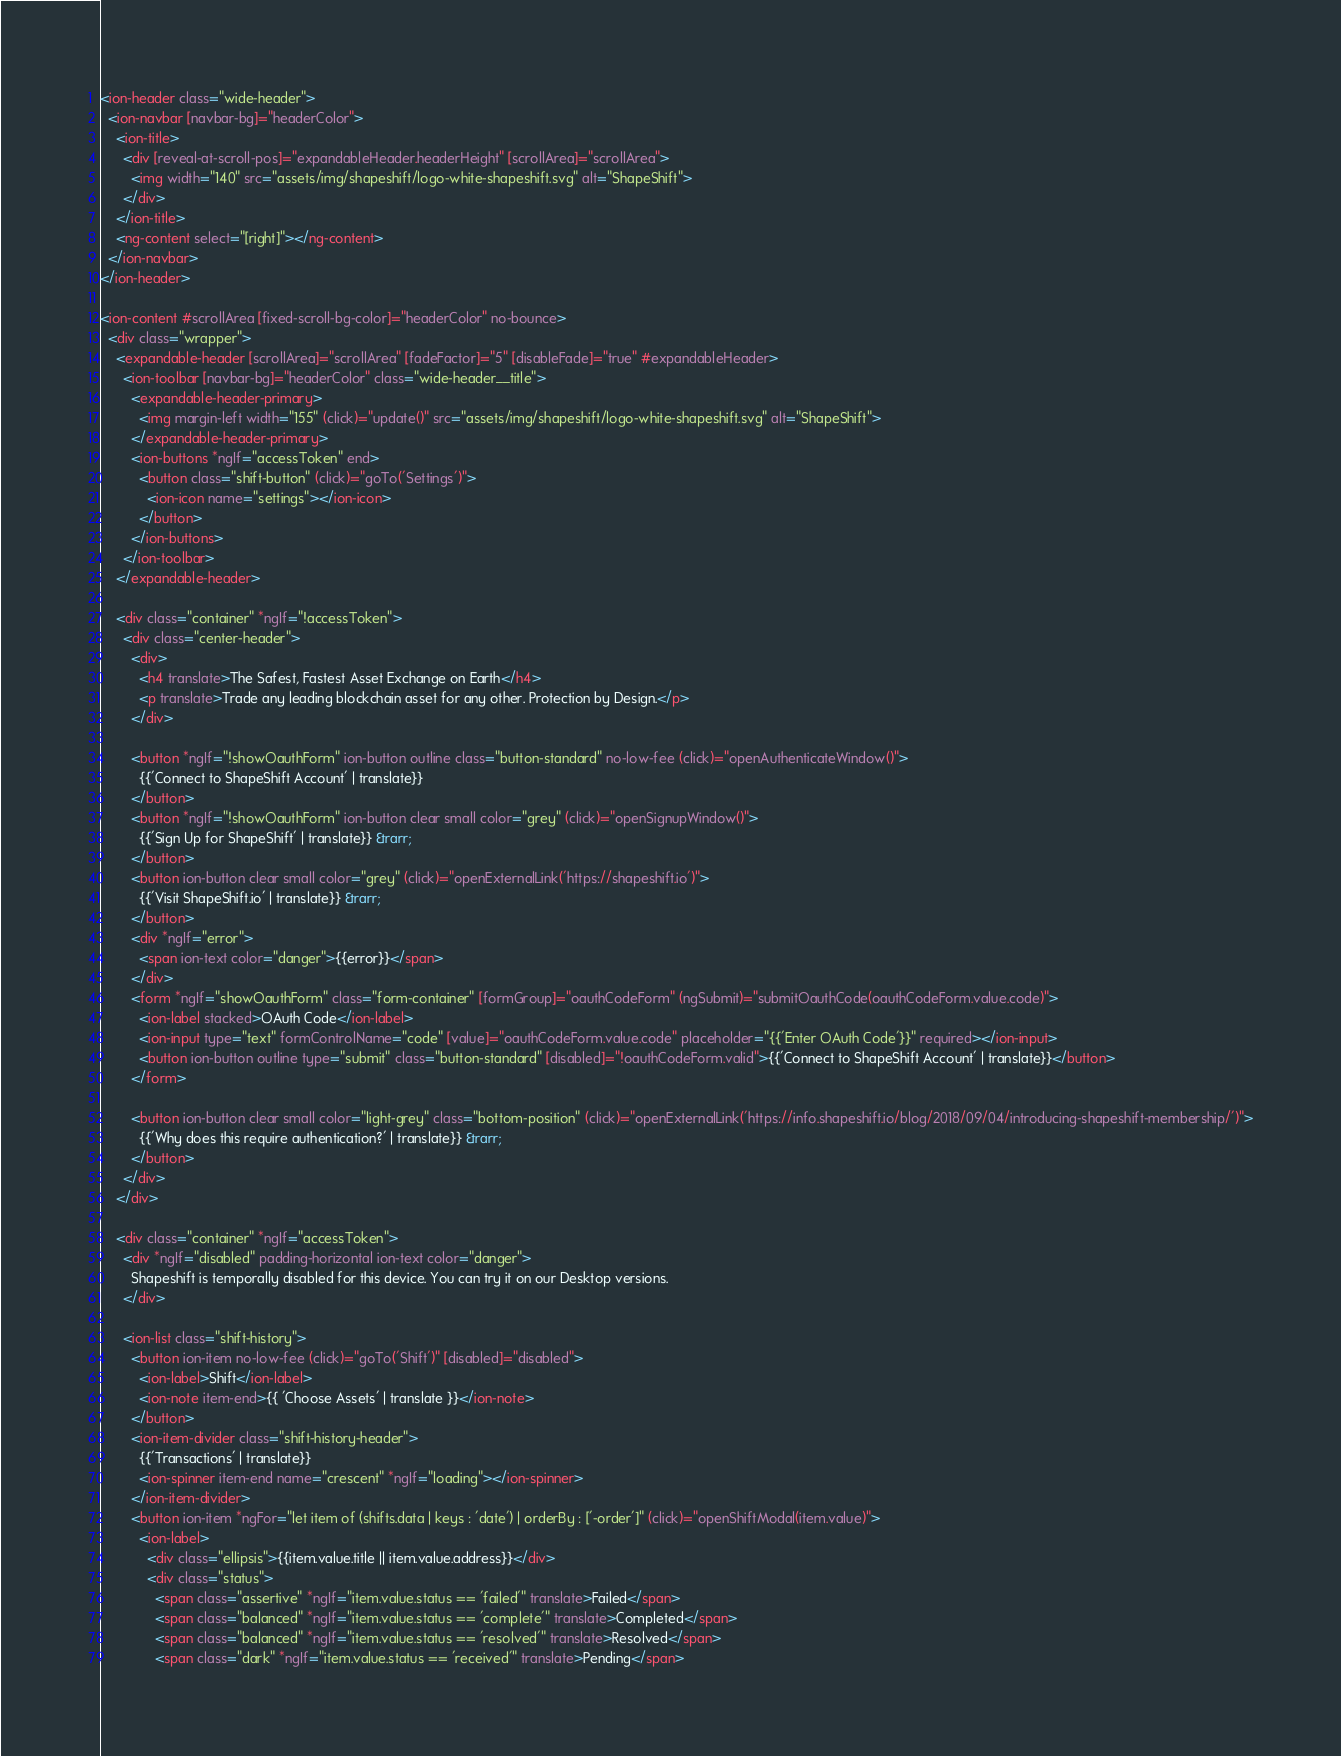Convert code to text. <code><loc_0><loc_0><loc_500><loc_500><_HTML_><ion-header class="wide-header">
  <ion-navbar [navbar-bg]="headerColor">
    <ion-title>
      <div [reveal-at-scroll-pos]="expandableHeader.headerHeight" [scrollArea]="scrollArea">
        <img width="140" src="assets/img/shapeshift/logo-white-shapeshift.svg" alt="ShapeShift">
      </div>
    </ion-title>
    <ng-content select="[right]"></ng-content>
  </ion-navbar>
</ion-header>

<ion-content #scrollArea [fixed-scroll-bg-color]="headerColor" no-bounce>
  <div class="wrapper">
    <expandable-header [scrollArea]="scrollArea" [fadeFactor]="5" [disableFade]="true" #expandableHeader>
      <ion-toolbar [navbar-bg]="headerColor" class="wide-header__title">
        <expandable-header-primary>
          <img margin-left width="155" (click)="update()" src="assets/img/shapeshift/logo-white-shapeshift.svg" alt="ShapeShift">
        </expandable-header-primary>
        <ion-buttons *ngIf="accessToken" end>
          <button class="shift-button" (click)="goTo('Settings')">
            <ion-icon name="settings"></ion-icon>
          </button>
        </ion-buttons>
      </ion-toolbar>
    </expandable-header>

    <div class="container" *ngIf="!accessToken">
      <div class="center-header">
        <div>
          <h4 translate>The Safest, Fastest Asset Exchange on Earth</h4>
          <p translate>Trade any leading blockchain asset for any other. Protection by Design.</p>
        </div>

        <button *ngIf="!showOauthForm" ion-button outline class="button-standard" no-low-fee (click)="openAuthenticateWindow()">
          {{'Connect to ShapeShift Account' | translate}}
        </button>
        <button *ngIf="!showOauthForm" ion-button clear small color="grey" (click)="openSignupWindow()">
          {{'Sign Up for ShapeShift' | translate}} &rarr;
        </button>
        <button ion-button clear small color="grey" (click)="openExternalLink('https://shapeshift.io')">
          {{'Visit ShapeShift.io' | translate}} &rarr;
        </button>
        <div *ngIf="error">
          <span ion-text color="danger">{{error}}</span>
        </div>
        <form *ngIf="showOauthForm" class="form-container" [formGroup]="oauthCodeForm" (ngSubmit)="submitOauthCode(oauthCodeForm.value.code)">
          <ion-label stacked>OAuth Code</ion-label>
          <ion-input type="text" formControlName="code" [value]="oauthCodeForm.value.code" placeholder="{{'Enter OAuth Code'}}" required></ion-input>
          <button ion-button outline type="submit" class="button-standard" [disabled]="!oauthCodeForm.valid">{{'Connect to ShapeShift Account' | translate}}</button>
        </form>

        <button ion-button clear small color="light-grey" class="bottom-position" (click)="openExternalLink('https://info.shapeshift.io/blog/2018/09/04/introducing-shapeshift-membership/')">
          {{'Why does this require authentication?' | translate}} &rarr;
        </button>
      </div>
    </div>

    <div class="container" *ngIf="accessToken">
      <div *ngIf="disabled" padding-horizontal ion-text color="danger">
        Shapeshift is temporally disabled for this device. You can try it on our Desktop versions.
      </div>

      <ion-list class="shift-history">
        <button ion-item no-low-fee (click)="goTo('Shift')" [disabled]="disabled">
          <ion-label>Shift</ion-label>
          <ion-note item-end>{{ 'Choose Assets' | translate }}</ion-note>
        </button>
        <ion-item-divider class="shift-history-header">
          {{'Transactions' | translate}}
          <ion-spinner item-end name="crescent" *ngIf="loading"></ion-spinner>
        </ion-item-divider>
        <button ion-item *ngFor="let item of (shifts.data | keys : 'date') | orderBy : ['-order']" (click)="openShiftModal(item.value)">
          <ion-label>
            <div class="ellipsis">{{item.value.title || item.value.address}}</div>
            <div class="status">
              <span class="assertive" *ngIf="item.value.status == 'failed'" translate>Failed</span>
              <span class="balanced" *ngIf="item.value.status == 'complete'" translate>Completed</span>
              <span class="balanced" *ngIf="item.value.status == 'resolved'" translate>Resolved</span>
              <span class="dark" *ngIf="item.value.status == 'received'" translate>Pending</span></code> 